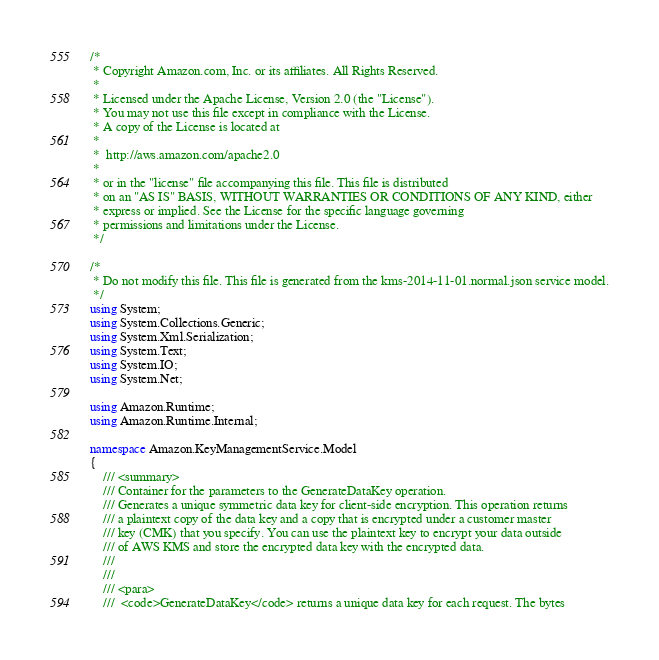<code> <loc_0><loc_0><loc_500><loc_500><_C#_>/*
 * Copyright Amazon.com, Inc. or its affiliates. All Rights Reserved.
 * 
 * Licensed under the Apache License, Version 2.0 (the "License").
 * You may not use this file except in compliance with the License.
 * A copy of the License is located at
 * 
 *  http://aws.amazon.com/apache2.0
 * 
 * or in the "license" file accompanying this file. This file is distributed
 * on an "AS IS" BASIS, WITHOUT WARRANTIES OR CONDITIONS OF ANY KIND, either
 * express or implied. See the License for the specific language governing
 * permissions and limitations under the License.
 */

/*
 * Do not modify this file. This file is generated from the kms-2014-11-01.normal.json service model.
 */
using System;
using System.Collections.Generic;
using System.Xml.Serialization;
using System.Text;
using System.IO;
using System.Net;

using Amazon.Runtime;
using Amazon.Runtime.Internal;

namespace Amazon.KeyManagementService.Model
{
    /// <summary>
    /// Container for the parameters to the GenerateDataKey operation.
    /// Generates a unique symmetric data key for client-side encryption. This operation returns
    /// a plaintext copy of the data key and a copy that is encrypted under a customer master
    /// key (CMK) that you specify. You can use the plaintext key to encrypt your data outside
    /// of AWS KMS and store the encrypted data key with the encrypted data.
    /// 
    ///  
    /// <para>
    ///  <code>GenerateDataKey</code> returns a unique data key for each request. The bytes</code> 